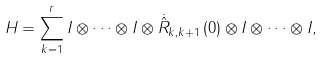<formula> <loc_0><loc_0><loc_500><loc_500>H = \sum _ { k = 1 } ^ { r } I \otimes \cdots \otimes I \otimes \dot { \hat { R } } _ { k , k + 1 } \left ( 0 \right ) \otimes I \otimes \cdots \otimes I ,</formula> 